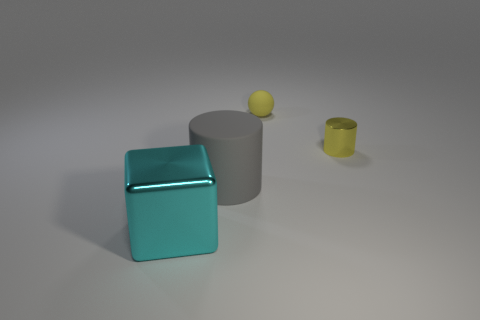What textures are visible on the objects in the scene? The blue cube appears to have a reflective, slightly metallic texture. The gray cylinder has a matte finish, and the small yellow sphere atop the gray cylinder seems to have a slightly rough, perhaps matte texture. Lastly, the yellow cylinder on the right also exhibits a metallic sheen. How is the lighting affecting the appearance of the objects? The scene is illuminated from the upper left corner, creating a soft shadow to the right of the objects. This highlights the reflective properties of the metallic textures on the blue cube and the yellow cylinder. The matte surfaces on the gray cylinder and the small yellow sphere absorb the light, minimizing reflections and creating a more uniform appearance. 